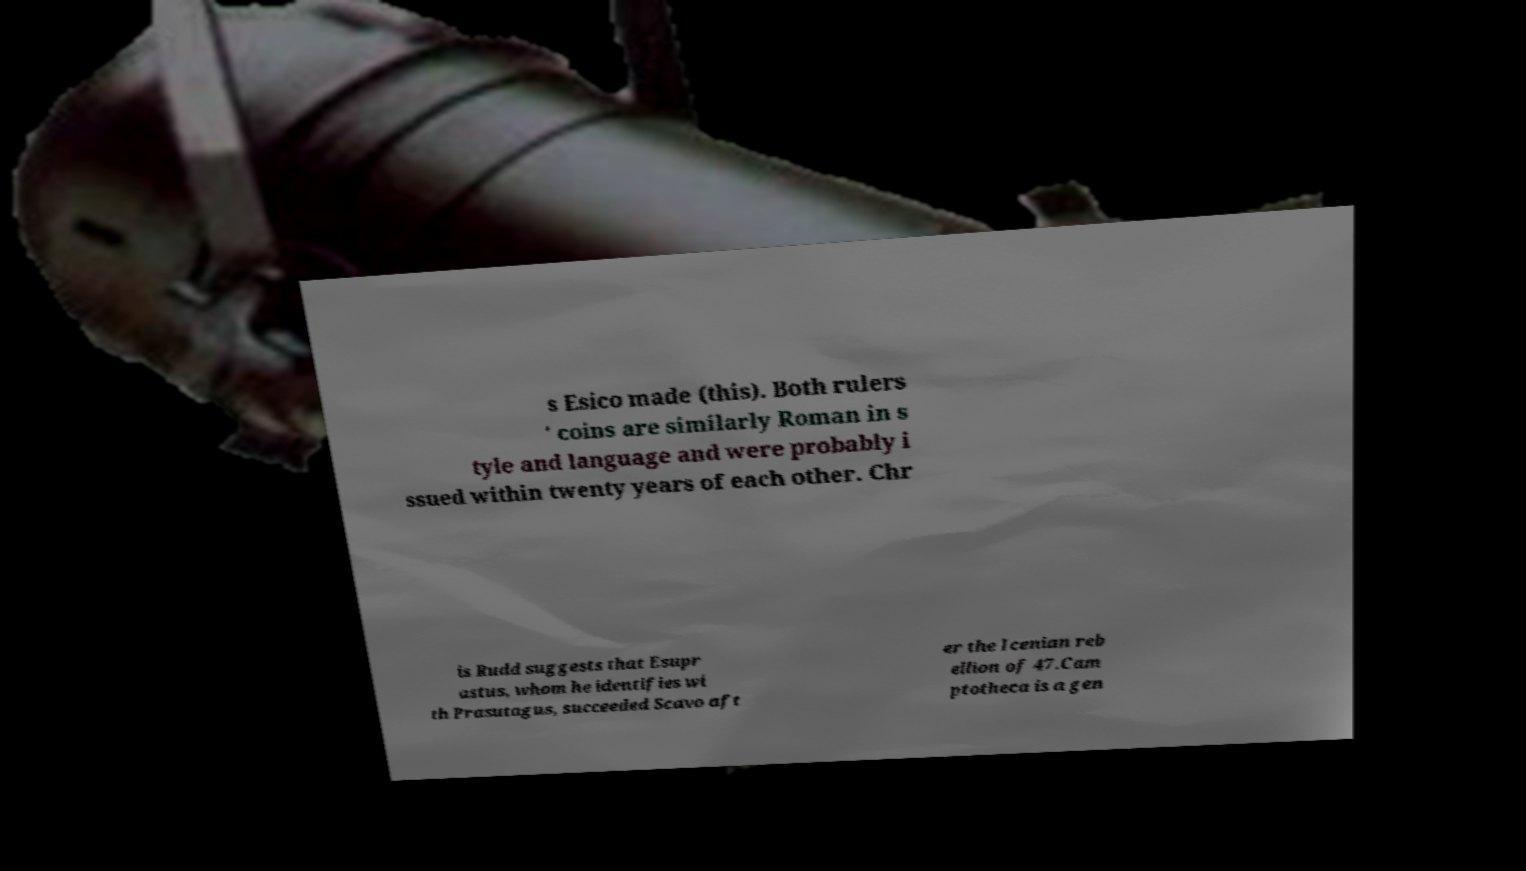Can you read and provide the text displayed in the image?This photo seems to have some interesting text. Can you extract and type it out for me? s Esico made (this). Both rulers ' coins are similarly Roman in s tyle and language and were probably i ssued within twenty years of each other. Chr is Rudd suggests that Esupr astus, whom he identifies wi th Prasutagus, succeeded Scavo aft er the Icenian reb ellion of 47.Cam ptotheca is a gen 